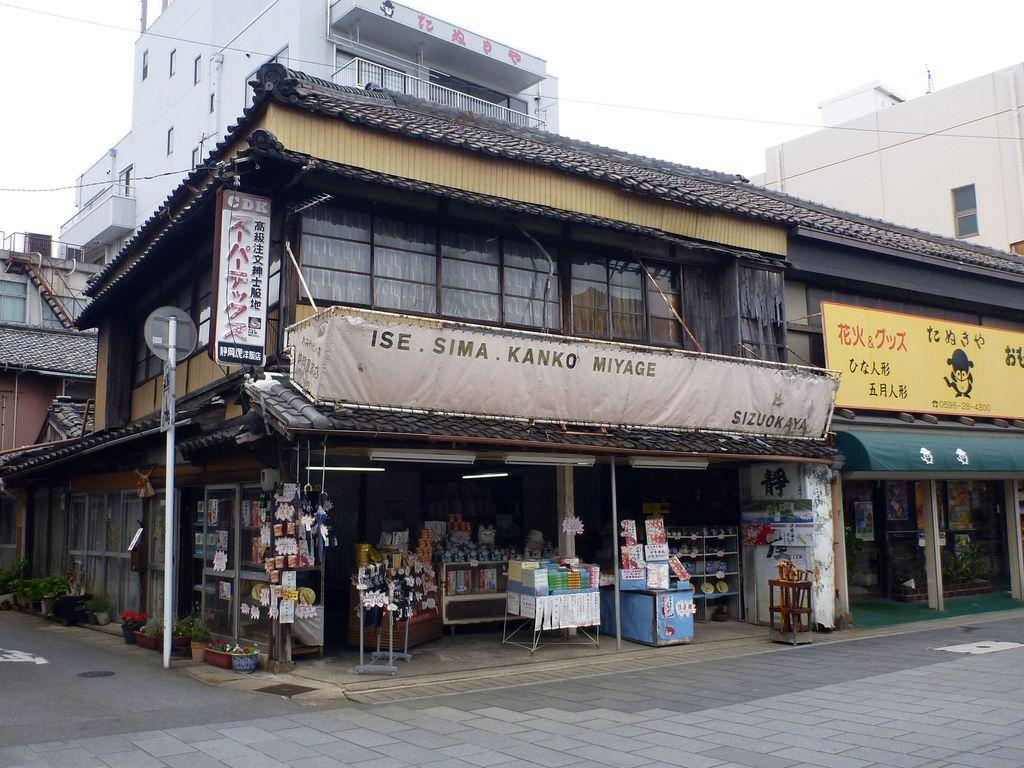What type of structures are present in the image? There are stalls in the image. What can be seen in the background of the image? There is a building in the background of the image. What is the color of the building? The building is white. What is attached to a pole in the image? There is a yellow board attached to a pole in the image. What is visible in the sky in the image? The sky is visible in the image, and it appears to be white. How many bottles of hope can be seen in the image? There are no bottles or any reference to hope present in the image. 